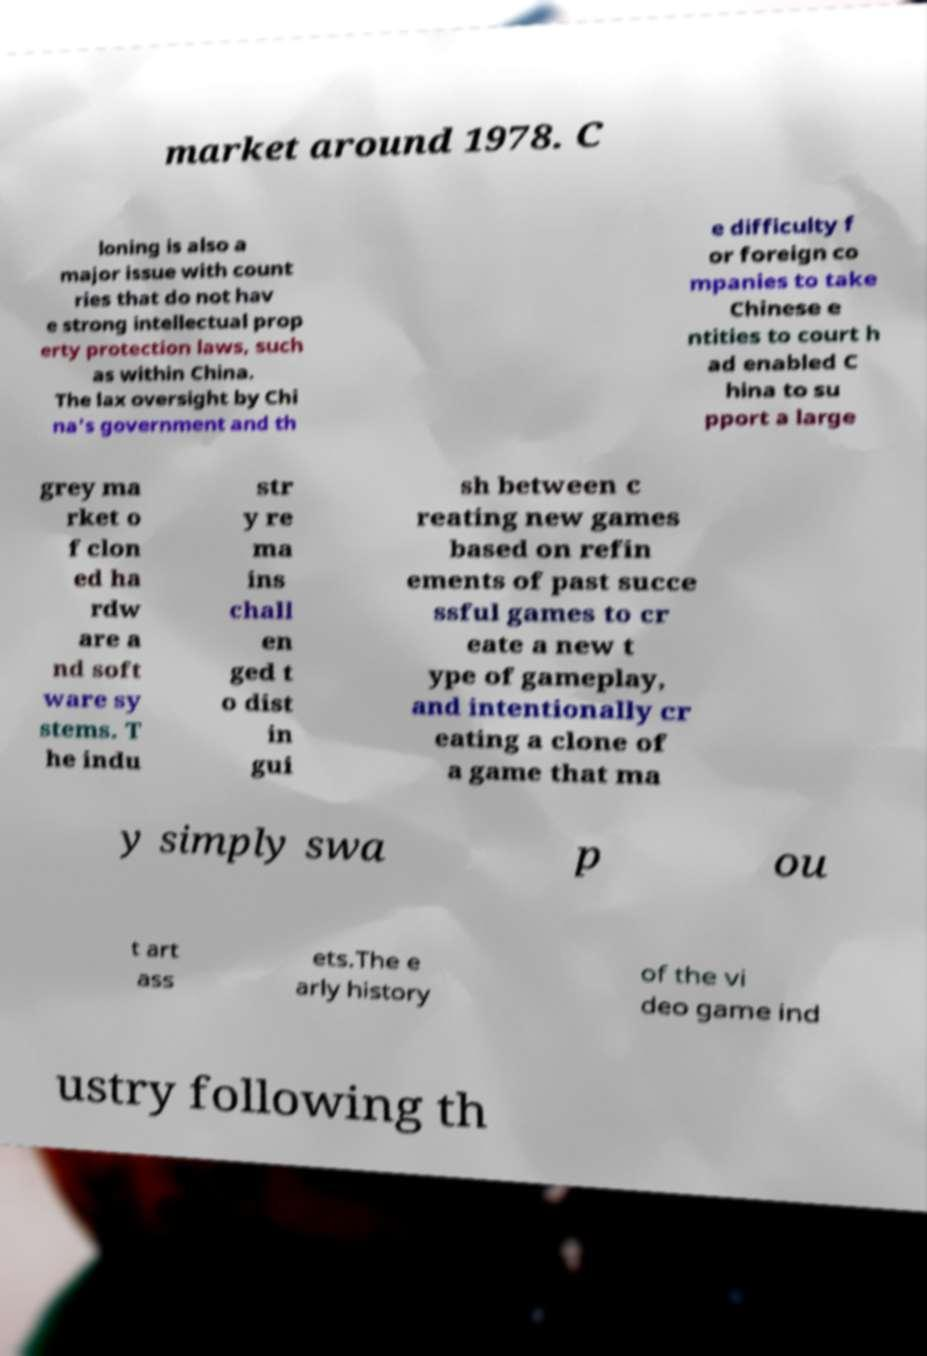Could you assist in decoding the text presented in this image and type it out clearly? market around 1978. C loning is also a major issue with count ries that do not hav e strong intellectual prop erty protection laws, such as within China. The lax oversight by Chi na's government and th e difficulty f or foreign co mpanies to take Chinese e ntities to court h ad enabled C hina to su pport a large grey ma rket o f clon ed ha rdw are a nd soft ware sy stems. T he indu str y re ma ins chall en ged t o dist in gui sh between c reating new games based on refin ements of past succe ssful games to cr eate a new t ype of gameplay, and intentionally cr eating a clone of a game that ma y simply swa p ou t art ass ets.The e arly history of the vi deo game ind ustry following th 